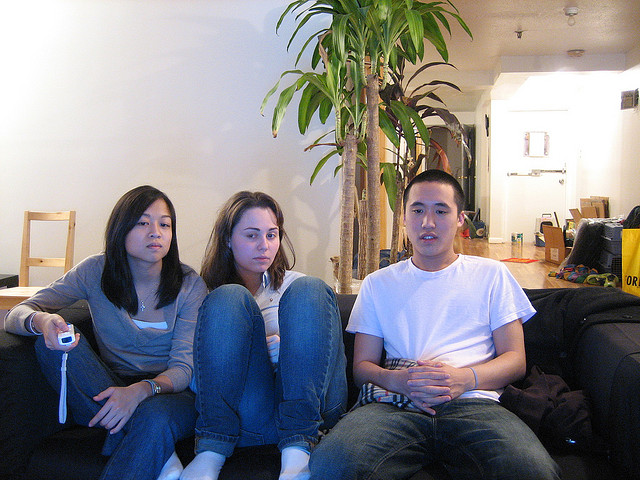<image>What are the flowers on the right side of the picture? I am not sure about the flowers on the right side. There might be no flowers, or they could be petunias or palm flowers. What are the flowers on the right side of the picture? I am not sure what the flowers on the right side of the picture are. It can be seen 'petunias', 'palms', 'plants', 'palm tree', or 'palm flowers'. 